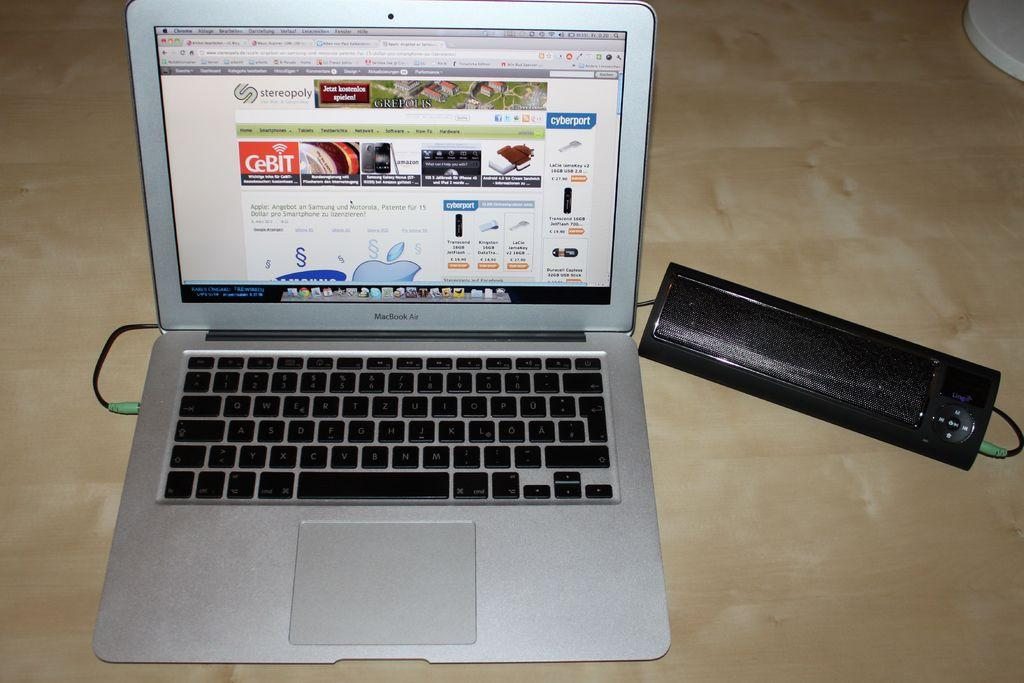<image>
Create a compact narrative representing the image presented. silver macbook air open with screen showing web page of different tech items 